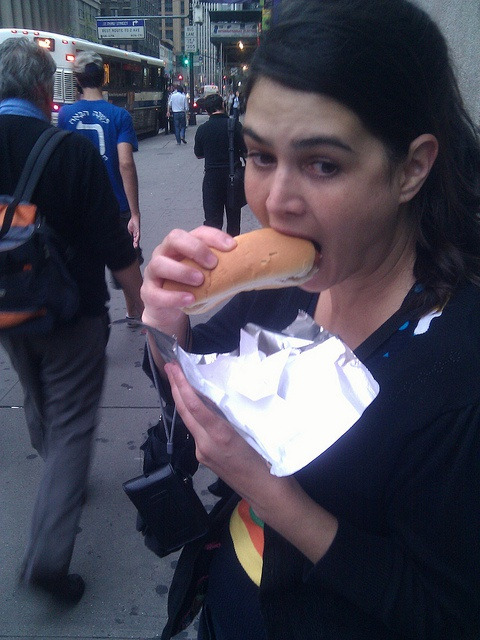Describe the objects in this image and their specific colors. I can see people in teal, black, and gray tones, people in teal, black, gray, and darkblue tones, backpack in teal, black, brown, maroon, and navy tones, hot dog in teal, salmon, and darkgray tones, and bus in teal, black, gray, white, and darkgray tones in this image. 